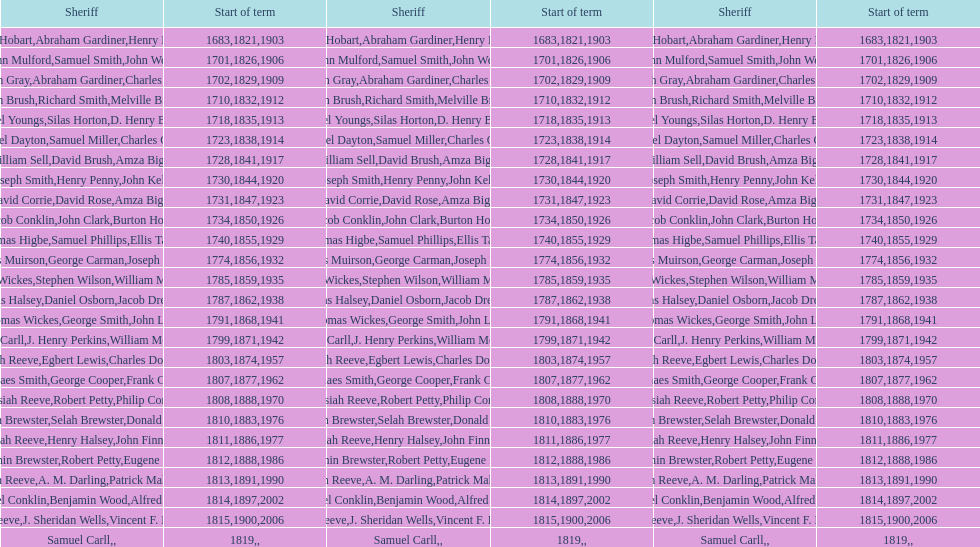Who occupied the sheriff role prior to thomas wickes? James Muirson. 